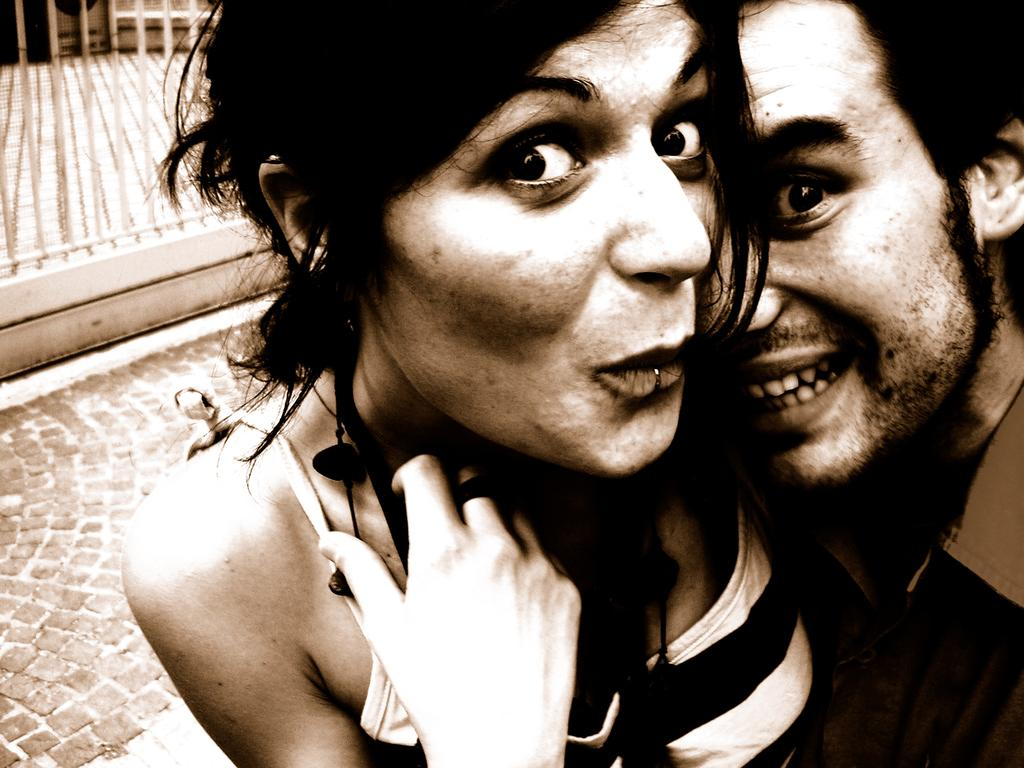Who are the people in the image? There is a man and a woman in the image. What are the man and woman doing in the image? The man and woman are hugging each other. What might be the reason for their pose? They are posing for a photograph. What can be seen in the background of the image? There is a footpath and fencing in the background of the image. What type of noise can be heard coming from the pan in the image? There is no pan present in the image, so no noise can be heard from it. 